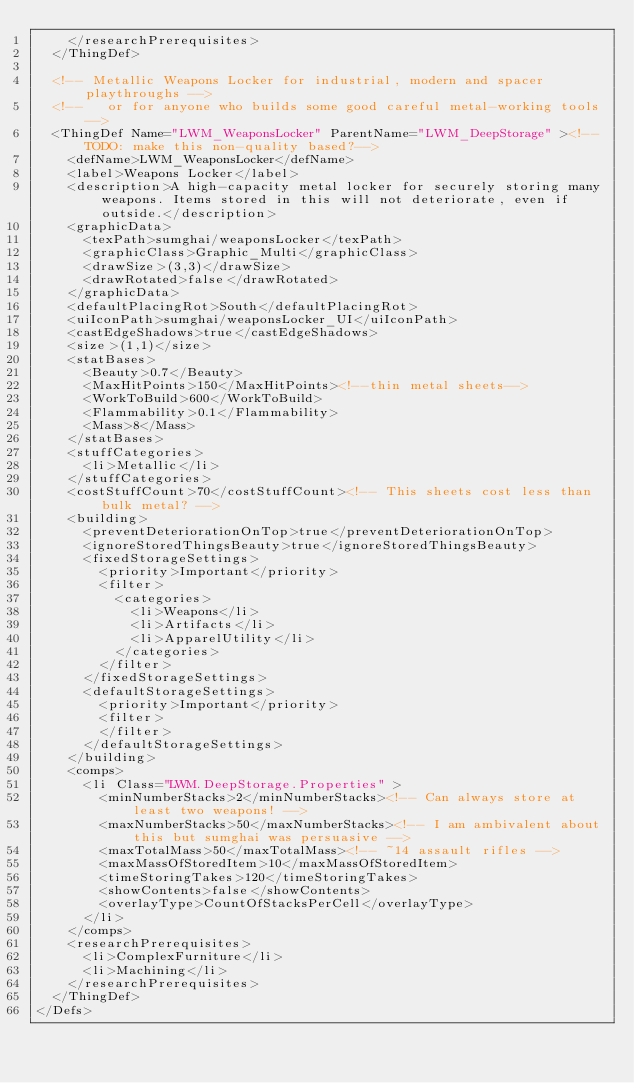<code> <loc_0><loc_0><loc_500><loc_500><_XML_>    </researchPrerequisites>
  </ThingDef>

  <!-- Metallic Weapons Locker for industrial, modern and spacer playthroughs -->
  <!--   or for anyone who builds some good careful metal-working tools -->	
  <ThingDef Name="LWM_WeaponsLocker" ParentName="LWM_DeepStorage" ><!--TODO: make this non-quality based?-->
    <defName>LWM_WeaponsLocker</defName>
    <label>Weapons Locker</label>
    <description>A high-capacity metal locker for securely storing many weapons. Items stored in this will not deteriorate, even if outside.</description>
    <graphicData>
      <texPath>sumghai/weaponsLocker</texPath>
      <graphicClass>Graphic_Multi</graphicClass>
      <drawSize>(3,3)</drawSize>
      <drawRotated>false</drawRotated>
    </graphicData>
    <defaultPlacingRot>South</defaultPlacingRot>
    <uiIconPath>sumghai/weaponsLocker_UI</uiIconPath>
    <castEdgeShadows>true</castEdgeShadows>
    <size>(1,1)</size>
    <statBases>
      <Beauty>0.7</Beauty>
      <MaxHitPoints>150</MaxHitPoints><!--thin metal sheets-->
      <WorkToBuild>600</WorkToBuild>
      <Flammability>0.1</Flammability>
      <Mass>8</Mass>
    </statBases>
    <stuffCategories>
      <li>Metallic</li>
    </stuffCategories>
    <costStuffCount>70</costStuffCount><!-- This sheets cost less than bulk metal? -->
    <building>
      <preventDeteriorationOnTop>true</preventDeteriorationOnTop>
      <ignoreStoredThingsBeauty>true</ignoreStoredThingsBeauty>
      <fixedStorageSettings>
        <priority>Important</priority>
        <filter>
          <categories>
            <li>Weapons</li>
            <li>Artifacts</li>
            <li>ApparelUtility</li>
          </categories>
        </filter>
      </fixedStorageSettings>
      <defaultStorageSettings>
        <priority>Important</priority>
        <filter>
        </filter>
      </defaultStorageSettings>
    </building>
    <comps>
      <li Class="LWM.DeepStorage.Properties" >
        <minNumberStacks>2</minNumberStacks><!-- Can always store at least two weapons! -->
        <maxNumberStacks>50</maxNumberStacks><!-- I am ambivalent about this but sumghai was persuasive -->
        <maxTotalMass>50</maxTotalMass><!-- ~14 assault rifles -->
        <maxMassOfStoredItem>10</maxMassOfStoredItem>
        <timeStoringTakes>120</timeStoringTakes>
        <showContents>false</showContents>
        <overlayType>CountOfStacksPerCell</overlayType>
      </li>
    </comps>
    <researchPrerequisites>
      <li>ComplexFurniture</li>
      <li>Machining</li>
    </researchPrerequisites>
  </ThingDef>
</Defs>
</code> 